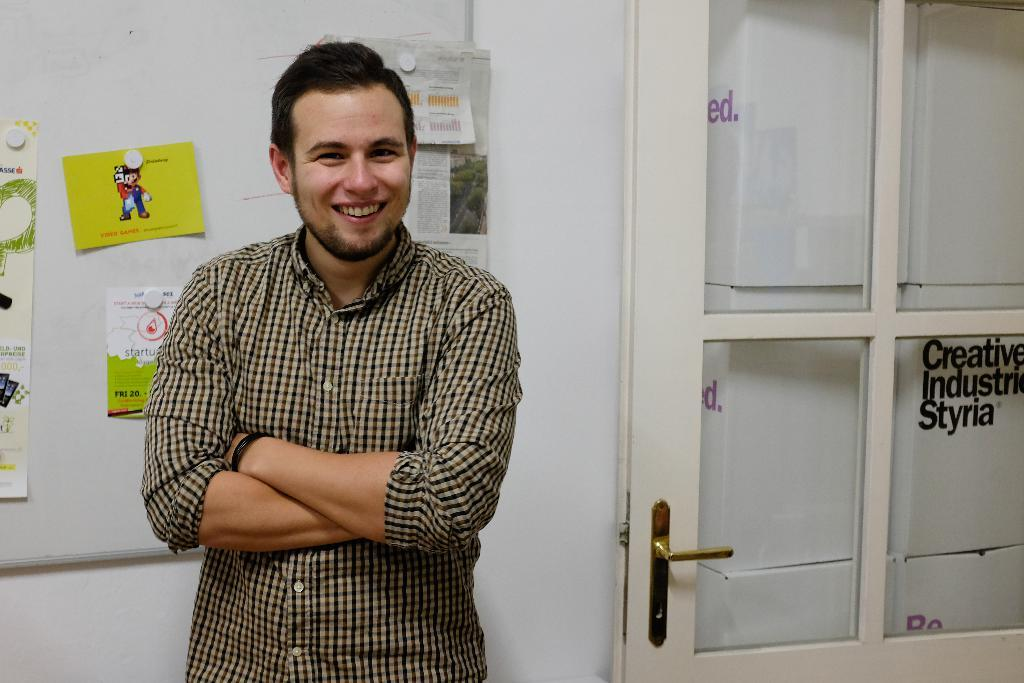Who or what is the main subject in the center of the image? There is a person in the center of the image. What can be seen in the background of the image? There is a wall and a door in the background of the image. Are there any objects or decorating the wall in the background? Yes, there are papers on the wall in the background of the image. What type of leather is covering the recess in the image? There is no leather or recess present in the image. 